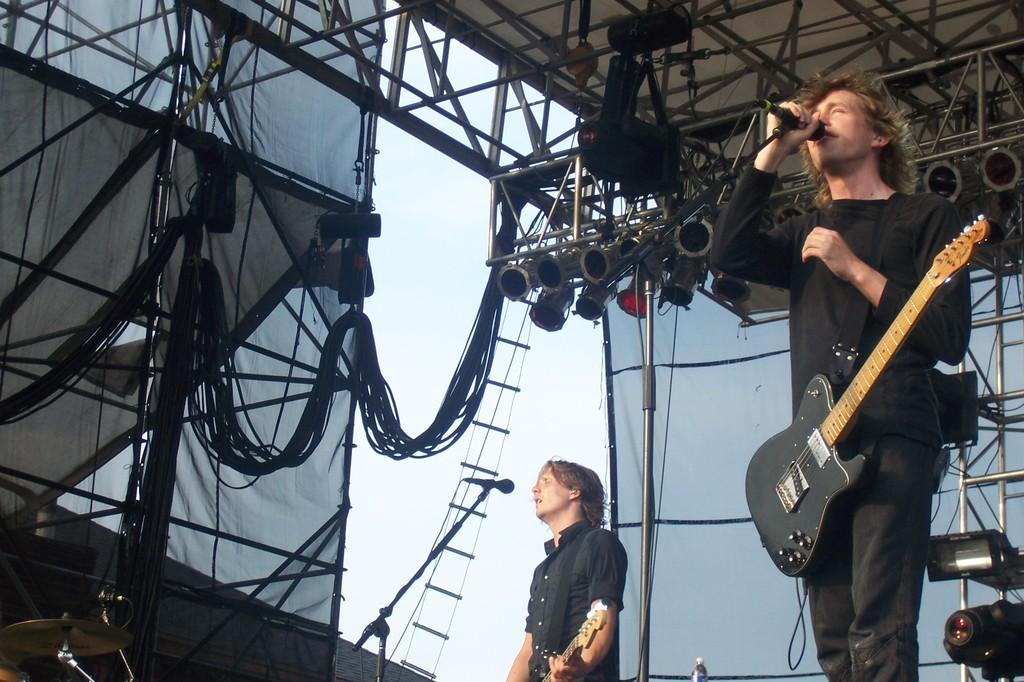Please provide a concise description of this image. The two people are performing on a stage. On the right side we have a person. He is standing. he's wearing a guitar. He's holding a mic and his singing a song. In the center we have a another person. He is simply like standing. He is holding a guitar. we can see in the background there is a curtain ,wires and sky. 